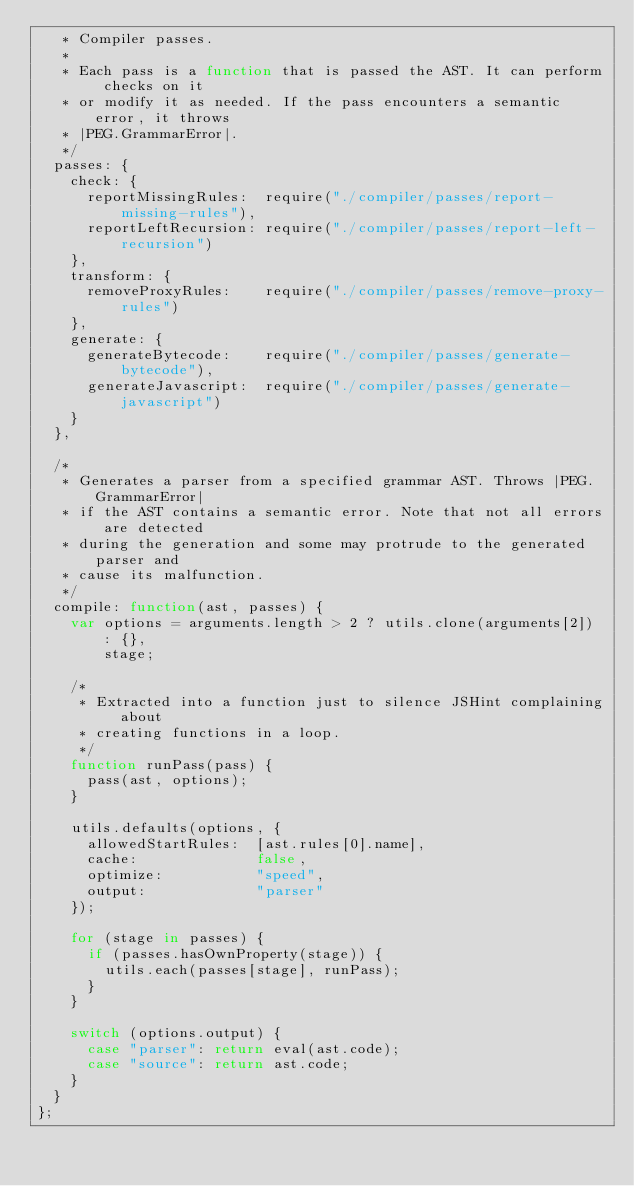<code> <loc_0><loc_0><loc_500><loc_500><_JavaScript_>   * Compiler passes.
   *
   * Each pass is a function that is passed the AST. It can perform checks on it
   * or modify it as needed. If the pass encounters a semantic error, it throws
   * |PEG.GrammarError|.
   */
  passes: {
    check: {
      reportMissingRules:  require("./compiler/passes/report-missing-rules"),
      reportLeftRecursion: require("./compiler/passes/report-left-recursion")
    },
    transform: {
      removeProxyRules:    require("./compiler/passes/remove-proxy-rules")
    },
    generate: {
      generateBytecode:    require("./compiler/passes/generate-bytecode"),
      generateJavascript:  require("./compiler/passes/generate-javascript")
    }
  },

  /*
   * Generates a parser from a specified grammar AST. Throws |PEG.GrammarError|
   * if the AST contains a semantic error. Note that not all errors are detected
   * during the generation and some may protrude to the generated parser and
   * cause its malfunction.
   */
  compile: function(ast, passes) {
    var options = arguments.length > 2 ? utils.clone(arguments[2]) : {},
        stage;

    /*
     * Extracted into a function just to silence JSHint complaining about
     * creating functions in a loop.
     */
    function runPass(pass) {
      pass(ast, options);
    }

    utils.defaults(options, {
      allowedStartRules:  [ast.rules[0].name],
      cache:              false,
      optimize:           "speed",
      output:             "parser"
    });

    for (stage in passes) {
      if (passes.hasOwnProperty(stage)) {
        utils.each(passes[stage], runPass);
      }
    }

    switch (options.output) {
      case "parser": return eval(ast.code);
      case "source": return ast.code;
    }
  }
};
</code> 